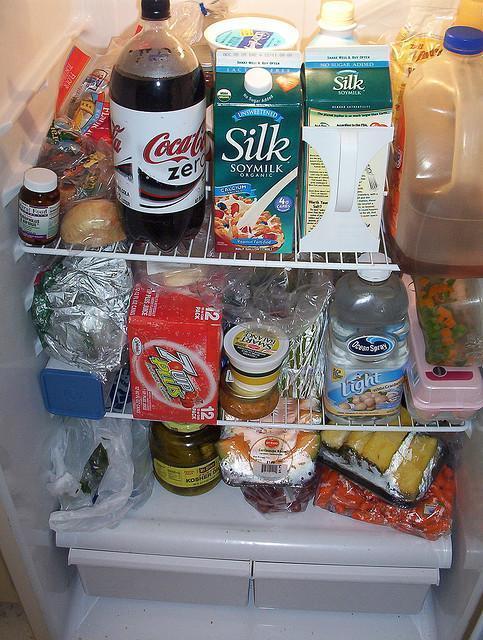How many bottles are in the picture?
Give a very brief answer. 5. How many people are carrying a skateboard?
Give a very brief answer. 0. 